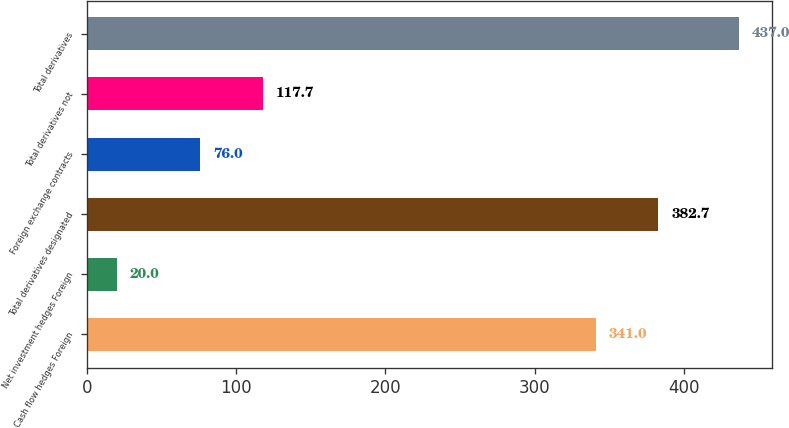<chart> <loc_0><loc_0><loc_500><loc_500><bar_chart><fcel>Cash flow hedges Foreign<fcel>Net investment hedges Foreign<fcel>Total derivatives designated<fcel>Foreign exchange contracts<fcel>Total derivatives not<fcel>Total derivatives<nl><fcel>341<fcel>20<fcel>382.7<fcel>76<fcel>117.7<fcel>437<nl></chart> 